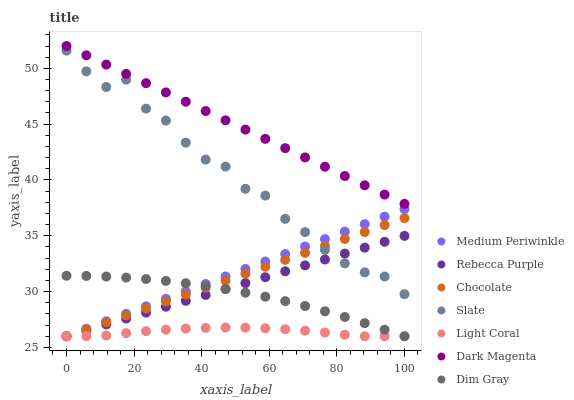Does Light Coral have the minimum area under the curve?
Answer yes or no. Yes. Does Dark Magenta have the maximum area under the curve?
Answer yes or no. Yes. Does Slate have the minimum area under the curve?
Answer yes or no. No. Does Slate have the maximum area under the curve?
Answer yes or no. No. Is Medium Periwinkle the smoothest?
Answer yes or no. Yes. Is Slate the roughest?
Answer yes or no. Yes. Is Dark Magenta the smoothest?
Answer yes or no. No. Is Dark Magenta the roughest?
Answer yes or no. No. Does Dim Gray have the lowest value?
Answer yes or no. Yes. Does Slate have the lowest value?
Answer yes or no. No. Does Dark Magenta have the highest value?
Answer yes or no. Yes. Does Slate have the highest value?
Answer yes or no. No. Is Medium Periwinkle less than Dark Magenta?
Answer yes or no. Yes. Is Dark Magenta greater than Slate?
Answer yes or no. Yes. Does Medium Periwinkle intersect Chocolate?
Answer yes or no. Yes. Is Medium Periwinkle less than Chocolate?
Answer yes or no. No. Is Medium Periwinkle greater than Chocolate?
Answer yes or no. No. Does Medium Periwinkle intersect Dark Magenta?
Answer yes or no. No. 